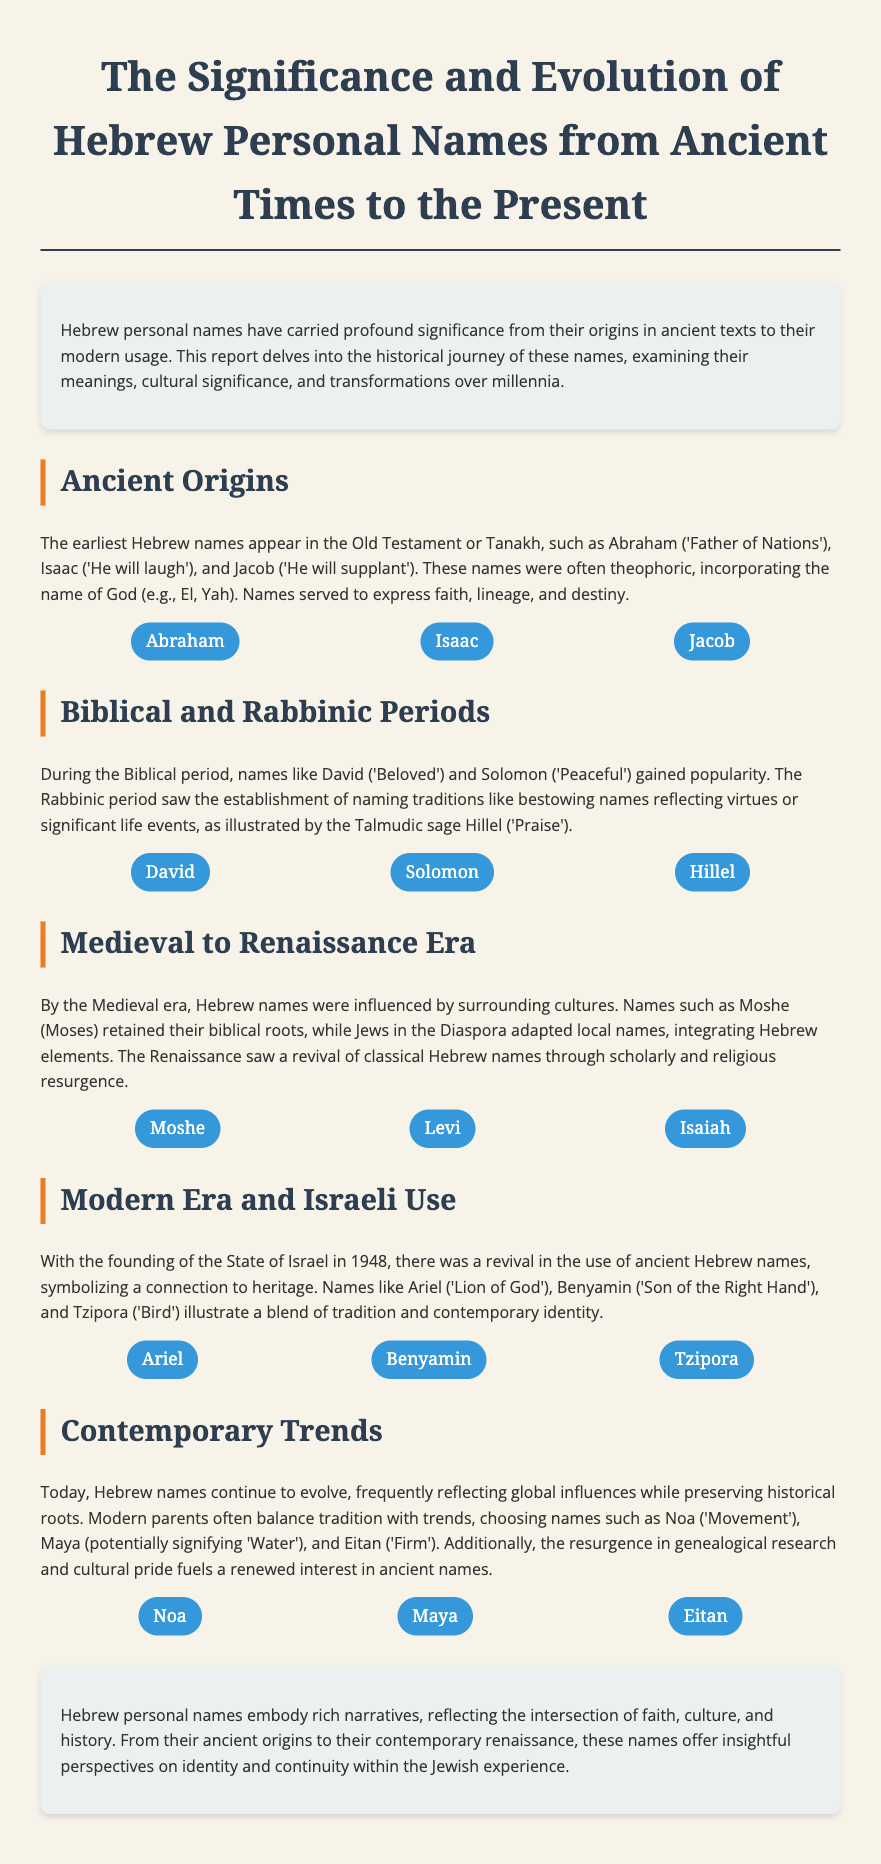What is the title of the report? The title of the report is stated at the top of the document.
Answer: The Significance and Evolution of Hebrew Personal Names from Ancient Times to the Present Who is mentioned as the 'Father of Nations'? This name is found under the Ancient Origins section, indicating its significance.
Answer: Abraham What does the name 'Hillel' mean? This information is provided in the Biblical and Rabbinic Periods section.
Answer: Praise In what year was the State of Israel founded? This date is referenced in the Modern Era and Israeli Use section.
Answer: 1948 Which names are listed in the Contemporary Trends section? This section provides examples of modern Hebrew names.
Answer: Noa, Maya, Eitan How many example names are provided in the Medieval to Renaissance Era section? The number is calculated based on the names listed in that section.
Answer: Three What is the significance of Hebrew names according to the conclusion? This is a summary statement that captures the essence of the report.
Answer: Identity and continuity What style of architecture is used in the document design? The style refers to the visual layout and overall aesthetics of the document.
Answer: Modern What biblical name means 'Peaceful'? This name is found under the Biblical and Rabbinic Periods section.
Answer: Solomon 